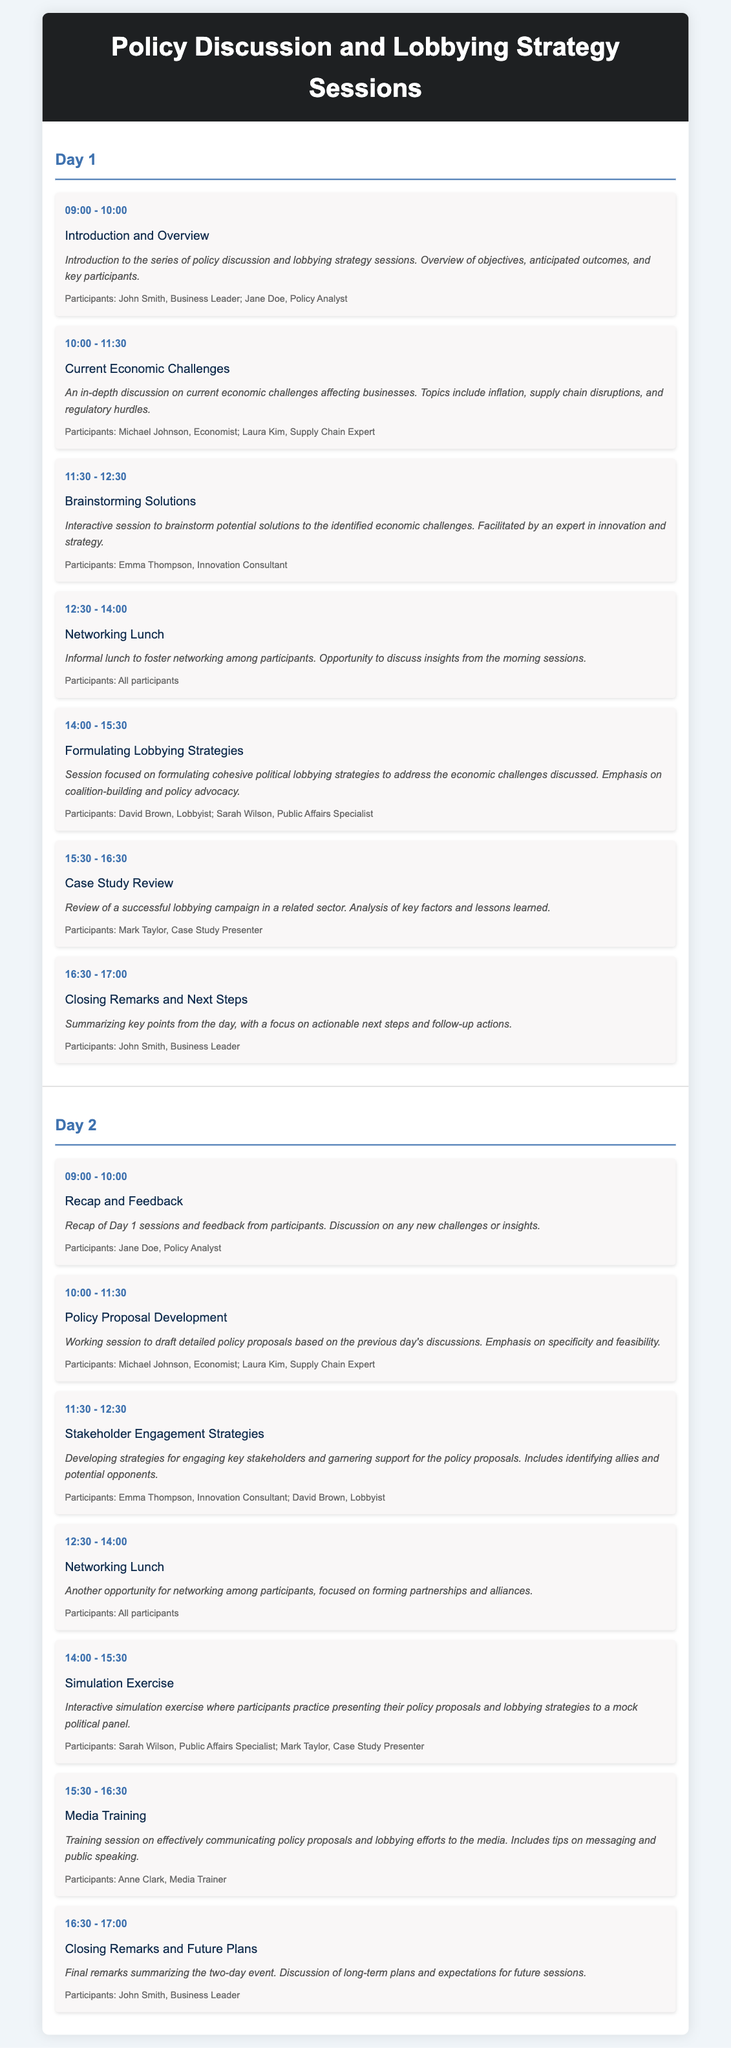What time does the "Current Economic Challenges" session start? The "Current Economic Challenges" session is scheduled to start at 10:00 AM.
Answer: 10:00 Who is the participant in the "Brainstorming Solutions" session? The participant in the "Brainstorming Solutions" session is listed as Emma Thompson, an Innovation Consultant.
Answer: Emma Thompson How long is the Networking Lunch on Day 1? The Networking Lunch on Day 1 lasts for 1 hour and 30 minutes, from 12:30 to 14:00.
Answer: 1 hour 30 minutes What session examines a previous lobbying campaign? The session that examines a previous lobbying campaign is titled "Case Study Review".
Answer: Case Study Review Which session is focused on Media Training? The session focused on Media Training is scheduled for the last hour of Day 2.
Answer: Media Training What is one of the key topics discussed in the "Current Economic Challenges" session? One of the key topics discussed is inflation.
Answer: Inflation How many sessions are scheduled for Day 2? There are six sessions scheduled for Day 2.
Answer: Six sessions Who leads the "Formulating Lobbying Strategies" session? David Brown, a Lobbyist, leads the "Formulating Lobbying Strategies" session.
Answer: David Brown What is included in the "Stakeholder Engagement Strategies" session? The session includes identifying allies and potential opponents.
Answer: Identifying allies and potential opponents 